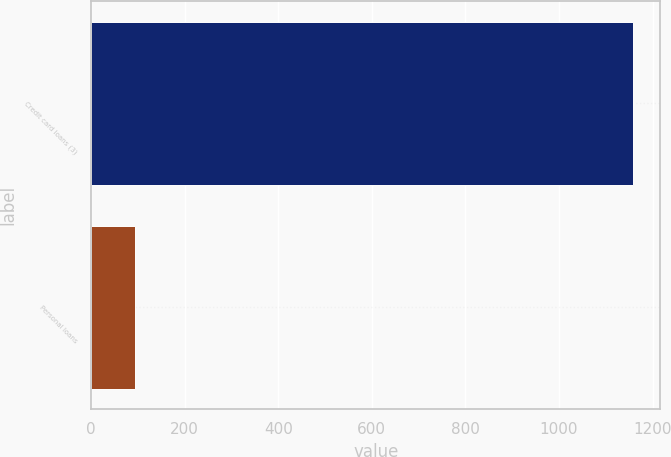Convert chart to OTSL. <chart><loc_0><loc_0><loc_500><loc_500><bar_chart><fcel>Credit card loans (3)<fcel>Personal loans<nl><fcel>1159<fcel>94<nl></chart> 